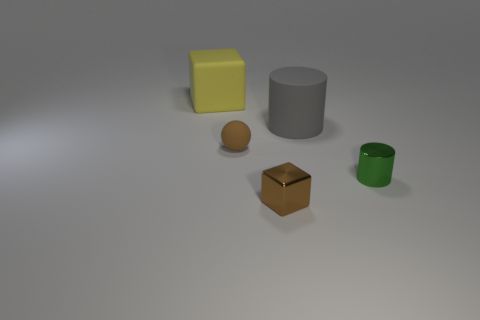What material is the sphere that is the same color as the shiny block?
Make the answer very short. Rubber. Is the material of the tiny sphere the same as the small brown cube?
Your response must be concise. No. What size is the gray object that is the same shape as the small green metal object?
Provide a succinct answer. Large. What material is the thing that is both behind the rubber ball and left of the large cylinder?
Offer a very short reply. Rubber. Are there the same number of tiny metallic things that are behind the yellow thing and brown matte spheres?
Give a very brief answer. No. What number of objects are either tiny brown things in front of the tiny rubber sphere or brown matte balls?
Provide a succinct answer. 2. There is a shiny object that is left of the gray rubber cylinder; does it have the same color as the small metallic cylinder?
Provide a short and direct response. No. There is a cube that is in front of the matte cylinder; what is its size?
Your answer should be compact. Small. What is the shape of the big thing on the right side of the big object that is left of the small brown ball?
Give a very brief answer. Cylinder. There is another large object that is the same shape as the green thing; what is its color?
Give a very brief answer. Gray. 